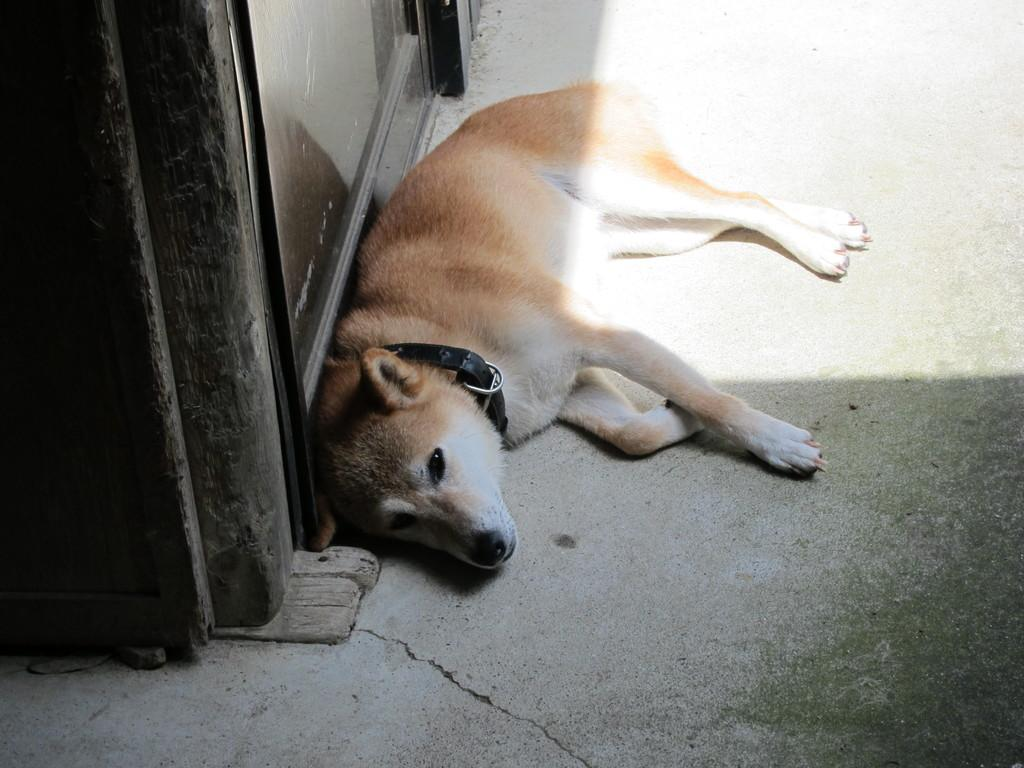What type of animal is present in the image? There is a dog in the image. Where is the dog located in the image? The dog is on the floor. What is visible on the left side of the image? There is a door on the left side of the image. Where is the lunchroom located in the image? There is no lunchroom present in the image. What type of love is being expressed by the dog in the image? The image does not depict any expression of love; it simply shows a dog on the floor. Is there a bear visible in the image? No, there is no bear present in the image. 